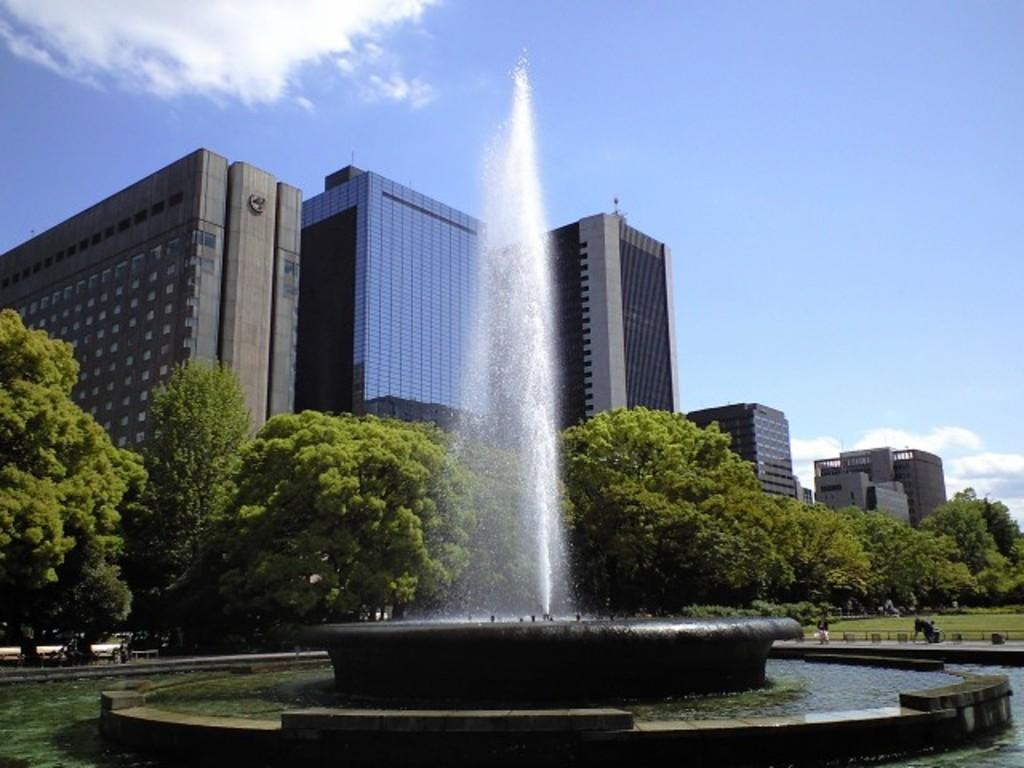What is the main feature of the image? The main feature of the image is a fountain. What is the setting of the image? The image features water, grass, trees, buildings, and objects, suggesting it is a park or garden. What can be seen in the background of the image? The sky is visible in the background of the image. How many faces can be seen on the trees in the image? There are no faces present on the trees in the image. What type of root is visible in the image? There is no root visible in the image. 